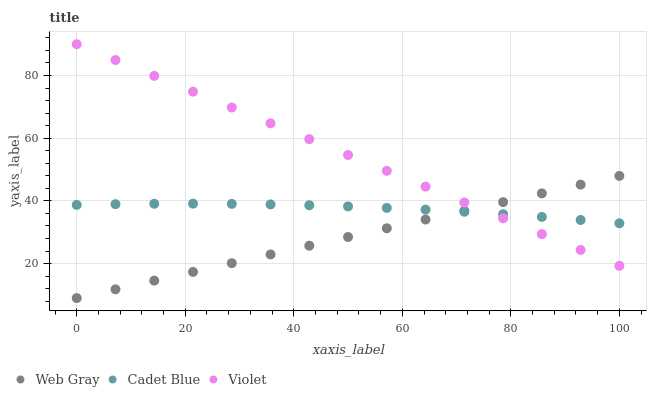Does Web Gray have the minimum area under the curve?
Answer yes or no. Yes. Does Violet have the maximum area under the curve?
Answer yes or no. Yes. Does Violet have the minimum area under the curve?
Answer yes or no. No. Does Web Gray have the maximum area under the curve?
Answer yes or no. No. Is Web Gray the smoothest?
Answer yes or no. Yes. Is Cadet Blue the roughest?
Answer yes or no. Yes. Is Violet the smoothest?
Answer yes or no. No. Is Violet the roughest?
Answer yes or no. No. Does Web Gray have the lowest value?
Answer yes or no. Yes. Does Violet have the lowest value?
Answer yes or no. No. Does Violet have the highest value?
Answer yes or no. Yes. Does Web Gray have the highest value?
Answer yes or no. No. Does Web Gray intersect Cadet Blue?
Answer yes or no. Yes. Is Web Gray less than Cadet Blue?
Answer yes or no. No. Is Web Gray greater than Cadet Blue?
Answer yes or no. No. 